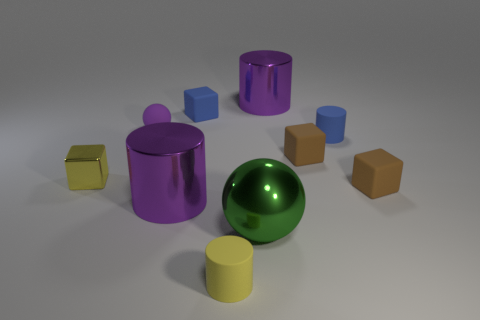Subtract all cylinders. How many objects are left? 6 Add 6 small yellow cylinders. How many small yellow cylinders are left? 7 Add 8 blue objects. How many blue objects exist? 10 Subtract 0 cyan spheres. How many objects are left? 10 Subtract all purple matte balls. Subtract all big green spheres. How many objects are left? 8 